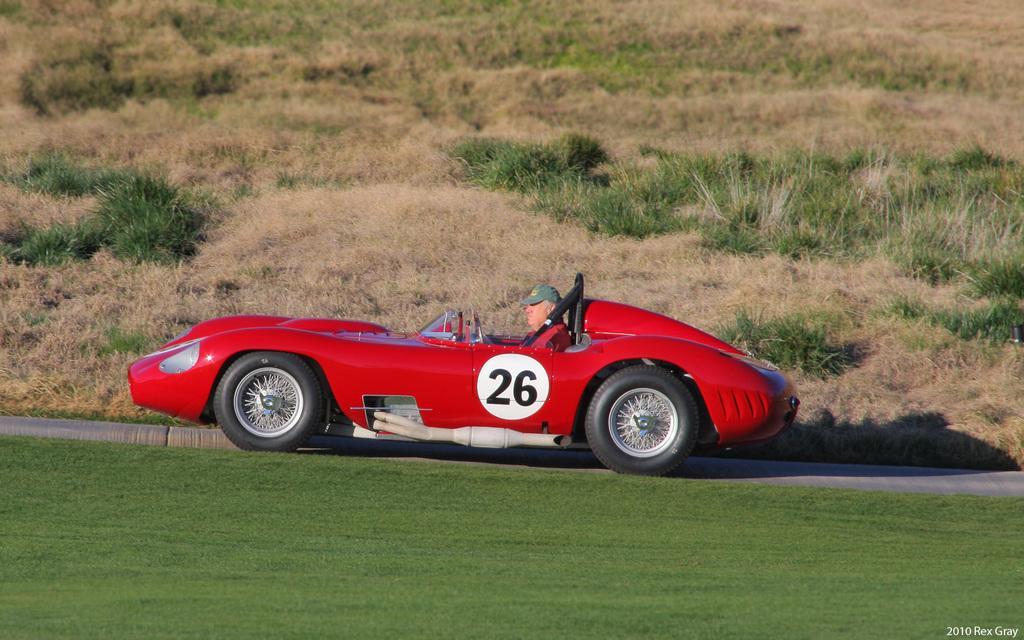Can you describe this image briefly? In this image there is a person sitting in a red color car which is on the grass, and in the background there are plants and a watermark on the image. 